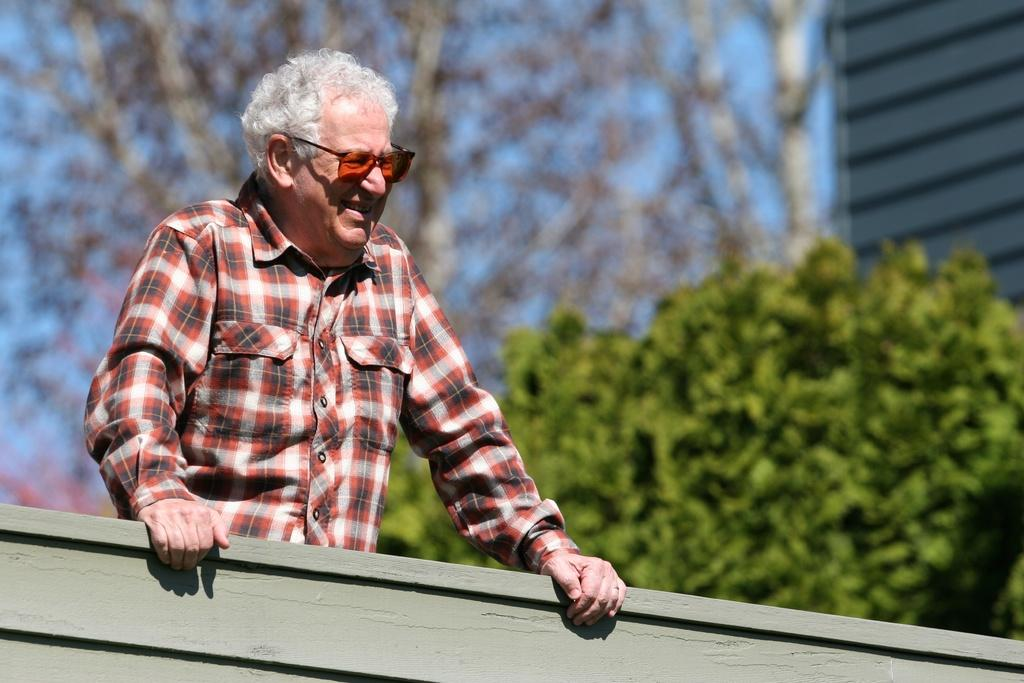What type of wall is visible in the front of the image? There is a wooden wall in the front of the image. Who is present in the center of the image? There is a man standing in the center of the image. What is the man's expression in the image? The man is smiling in the image. What can be seen in the background of the image? There are trees and a building in the background of the image. What type of amusement can be seen in the image? There is no amusement present in the image; it features a man standing in front of a wooden wall with trees and a building in the background. Can you tell me how many scissors are visible in the image? There are no scissors present in the image. 